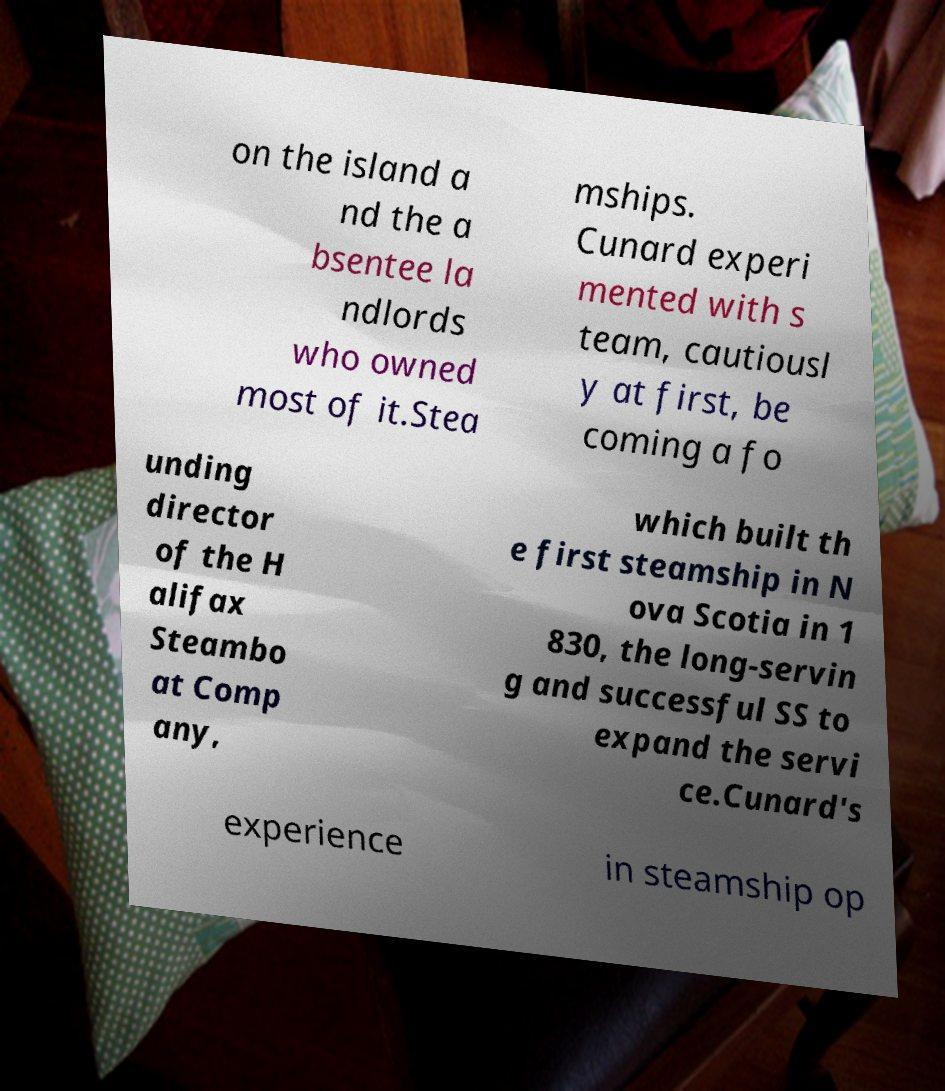Please read and relay the text visible in this image. What does it say? on the island a nd the a bsentee la ndlords who owned most of it.Stea mships. Cunard experi mented with s team, cautiousl y at first, be coming a fo unding director of the H alifax Steambo at Comp any, which built th e first steamship in N ova Scotia in 1 830, the long-servin g and successful SS to expand the servi ce.Cunard's experience in steamship op 